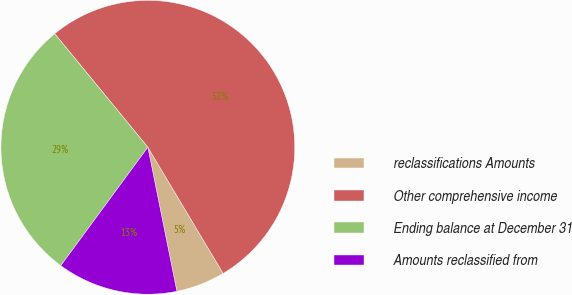Convert chart. <chart><loc_0><loc_0><loc_500><loc_500><pie_chart><fcel>reclassifications Amounts<fcel>Other comprehensive income<fcel>Ending balance at December 31<fcel>Amounts reclassified from<nl><fcel>5.4%<fcel>52.37%<fcel>28.97%<fcel>13.26%<nl></chart> 